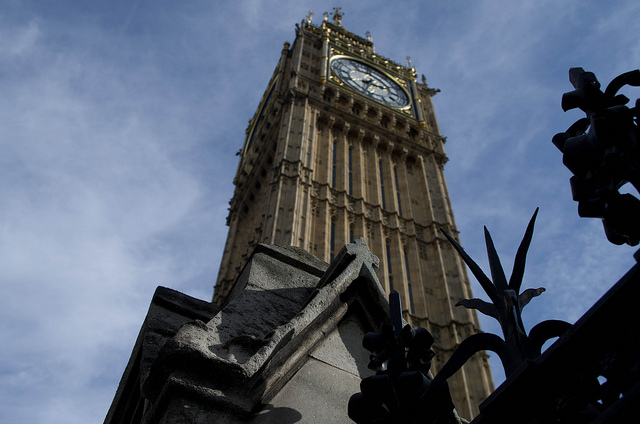<image>What shape is the rooftop below the clock? I am not sure what shape is the rooftop below the clock. It can be seen as triangle, square or round. What shape is the rooftop below the clock? I don't know what shape is the rooftop below the clock. It can be seen as a triangular shape, but I am not sure. 